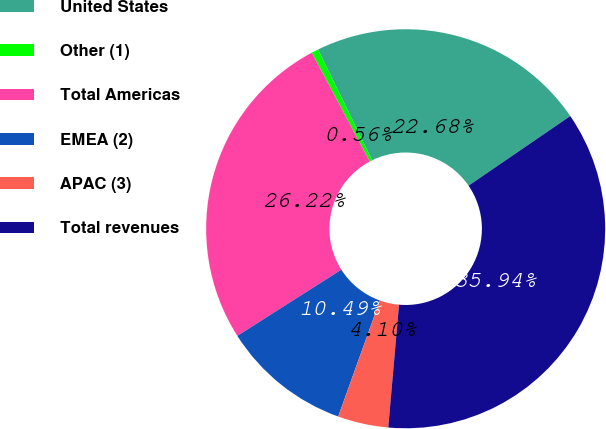Convert chart. <chart><loc_0><loc_0><loc_500><loc_500><pie_chart><fcel>United States<fcel>Other (1)<fcel>Total Americas<fcel>EMEA (2)<fcel>APAC (3)<fcel>Total revenues<nl><fcel>22.68%<fcel>0.56%<fcel>26.22%<fcel>10.49%<fcel>4.1%<fcel>35.94%<nl></chart> 